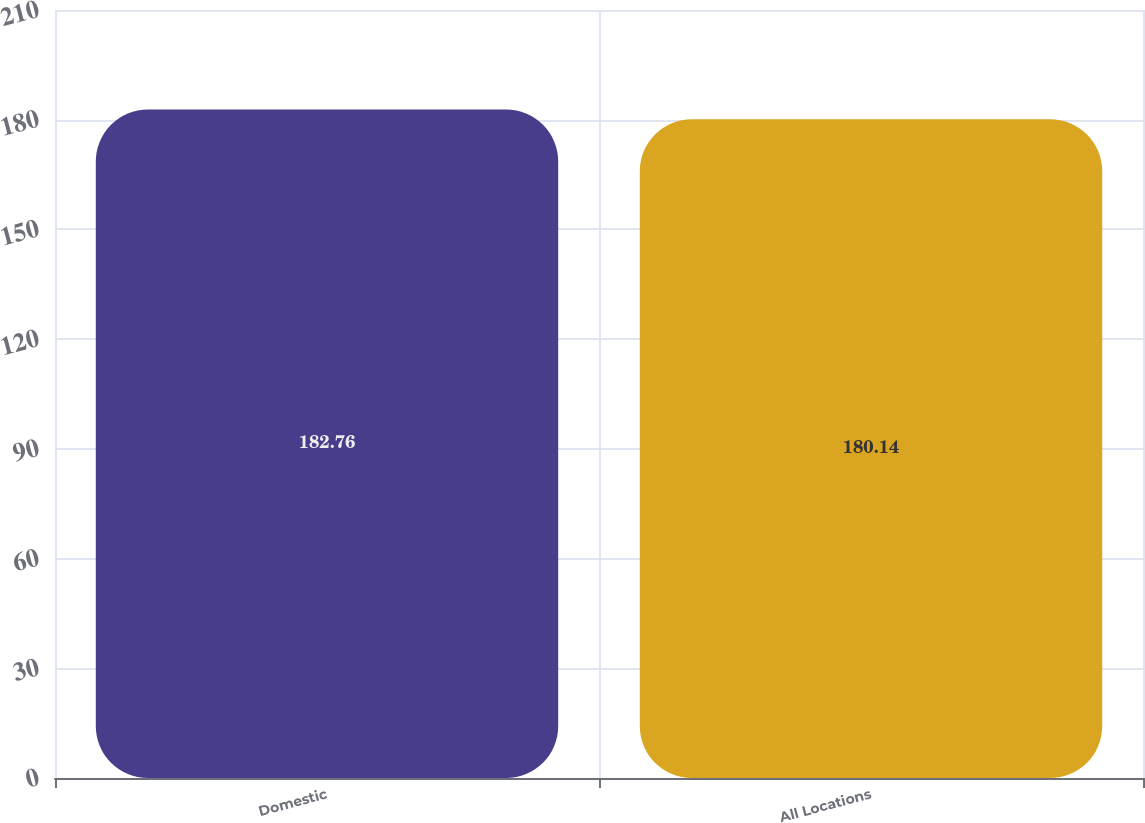Convert chart to OTSL. <chart><loc_0><loc_0><loc_500><loc_500><bar_chart><fcel>Domestic<fcel>All Locations<nl><fcel>182.76<fcel>180.14<nl></chart> 